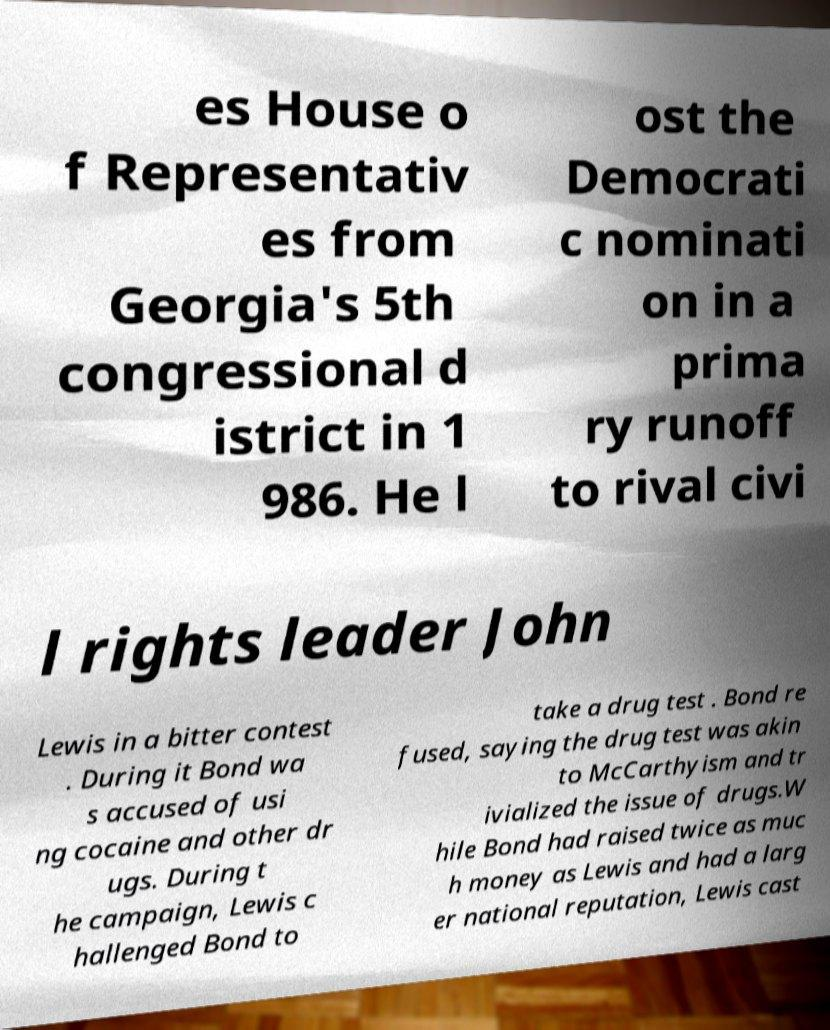For documentation purposes, I need the text within this image transcribed. Could you provide that? es House o f Representativ es from Georgia's 5th congressional d istrict in 1 986. He l ost the Democrati c nominati on in a prima ry runoff to rival civi l rights leader John Lewis in a bitter contest . During it Bond wa s accused of usi ng cocaine and other dr ugs. During t he campaign, Lewis c hallenged Bond to take a drug test . Bond re fused, saying the drug test was akin to McCarthyism and tr ivialized the issue of drugs.W hile Bond had raised twice as muc h money as Lewis and had a larg er national reputation, Lewis cast 